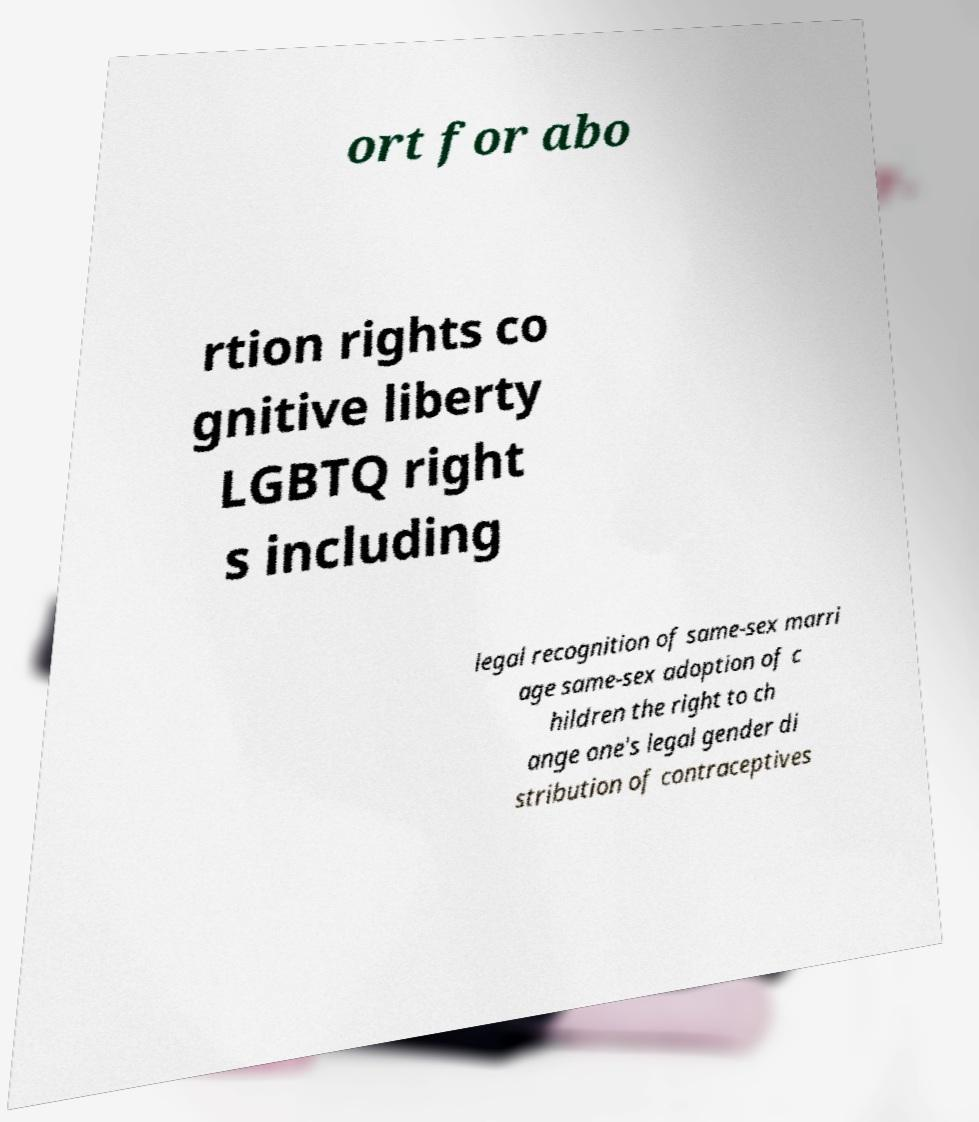Can you accurately transcribe the text from the provided image for me? ort for abo rtion rights co gnitive liberty LGBTQ right s including legal recognition of same-sex marri age same-sex adoption of c hildren the right to ch ange one's legal gender di stribution of contraceptives 